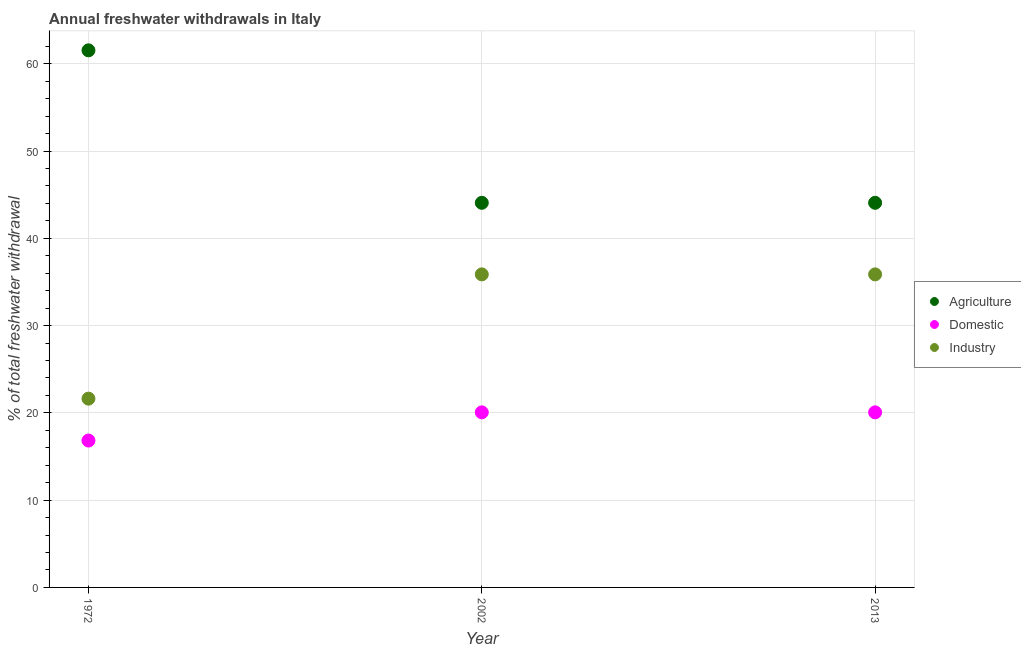How many different coloured dotlines are there?
Provide a succinct answer. 3. Is the number of dotlines equal to the number of legend labels?
Your response must be concise. Yes. What is the percentage of freshwater withdrawal for domestic purposes in 2013?
Give a very brief answer. 20.06. Across all years, what is the maximum percentage of freshwater withdrawal for industry?
Your answer should be very brief. 35.87. Across all years, what is the minimum percentage of freshwater withdrawal for agriculture?
Keep it short and to the point. 44.07. What is the total percentage of freshwater withdrawal for domestic purposes in the graph?
Offer a terse response. 56.95. What is the difference between the percentage of freshwater withdrawal for agriculture in 1972 and that in 2013?
Provide a succinct answer. 17.47. What is the difference between the percentage of freshwater withdrawal for domestic purposes in 2013 and the percentage of freshwater withdrawal for agriculture in 2002?
Give a very brief answer. -24.01. What is the average percentage of freshwater withdrawal for domestic purposes per year?
Your response must be concise. 18.98. In the year 2013, what is the difference between the percentage of freshwater withdrawal for agriculture and percentage of freshwater withdrawal for industry?
Provide a succinct answer. 8.2. In how many years, is the percentage of freshwater withdrawal for agriculture greater than 54 %?
Provide a short and direct response. 1. What is the ratio of the percentage of freshwater withdrawal for industry in 2002 to that in 2013?
Provide a succinct answer. 1. Is the percentage of freshwater withdrawal for industry in 2002 less than that in 2013?
Provide a short and direct response. No. What is the difference between the highest and the second highest percentage of freshwater withdrawal for agriculture?
Your answer should be compact. 17.47. What is the difference between the highest and the lowest percentage of freshwater withdrawal for industry?
Ensure brevity in your answer.  14.24. In how many years, is the percentage of freshwater withdrawal for industry greater than the average percentage of freshwater withdrawal for industry taken over all years?
Your answer should be compact. 2. Is it the case that in every year, the sum of the percentage of freshwater withdrawal for agriculture and percentage of freshwater withdrawal for domestic purposes is greater than the percentage of freshwater withdrawal for industry?
Your response must be concise. Yes. Does the percentage of freshwater withdrawal for domestic purposes monotonically increase over the years?
Keep it short and to the point. No. Is the percentage of freshwater withdrawal for industry strictly greater than the percentage of freshwater withdrawal for agriculture over the years?
Provide a succinct answer. No. How many dotlines are there?
Keep it short and to the point. 3. How many years are there in the graph?
Your response must be concise. 3. Are the values on the major ticks of Y-axis written in scientific E-notation?
Your answer should be compact. No. Does the graph contain any zero values?
Provide a succinct answer. No. How many legend labels are there?
Offer a terse response. 3. What is the title of the graph?
Give a very brief answer. Annual freshwater withdrawals in Italy. What is the label or title of the X-axis?
Keep it short and to the point. Year. What is the label or title of the Y-axis?
Offer a very short reply. % of total freshwater withdrawal. What is the % of total freshwater withdrawal in Agriculture in 1972?
Your answer should be compact. 61.54. What is the % of total freshwater withdrawal in Domestic in 1972?
Your answer should be compact. 16.83. What is the % of total freshwater withdrawal of Industry in 1972?
Make the answer very short. 21.63. What is the % of total freshwater withdrawal of Agriculture in 2002?
Give a very brief answer. 44.07. What is the % of total freshwater withdrawal in Domestic in 2002?
Your response must be concise. 20.06. What is the % of total freshwater withdrawal in Industry in 2002?
Ensure brevity in your answer.  35.87. What is the % of total freshwater withdrawal in Agriculture in 2013?
Your answer should be compact. 44.07. What is the % of total freshwater withdrawal of Domestic in 2013?
Your answer should be compact. 20.06. What is the % of total freshwater withdrawal of Industry in 2013?
Keep it short and to the point. 35.87. Across all years, what is the maximum % of total freshwater withdrawal in Agriculture?
Your response must be concise. 61.54. Across all years, what is the maximum % of total freshwater withdrawal of Domestic?
Make the answer very short. 20.06. Across all years, what is the maximum % of total freshwater withdrawal in Industry?
Your response must be concise. 35.87. Across all years, what is the minimum % of total freshwater withdrawal of Agriculture?
Provide a short and direct response. 44.07. Across all years, what is the minimum % of total freshwater withdrawal in Domestic?
Give a very brief answer. 16.83. Across all years, what is the minimum % of total freshwater withdrawal in Industry?
Your response must be concise. 21.63. What is the total % of total freshwater withdrawal in Agriculture in the graph?
Provide a short and direct response. 149.68. What is the total % of total freshwater withdrawal of Domestic in the graph?
Keep it short and to the point. 56.95. What is the total % of total freshwater withdrawal of Industry in the graph?
Keep it short and to the point. 93.37. What is the difference between the % of total freshwater withdrawal of Agriculture in 1972 and that in 2002?
Offer a terse response. 17.47. What is the difference between the % of total freshwater withdrawal of Domestic in 1972 and that in 2002?
Give a very brief answer. -3.23. What is the difference between the % of total freshwater withdrawal of Industry in 1972 and that in 2002?
Ensure brevity in your answer.  -14.24. What is the difference between the % of total freshwater withdrawal in Agriculture in 1972 and that in 2013?
Provide a succinct answer. 17.47. What is the difference between the % of total freshwater withdrawal in Domestic in 1972 and that in 2013?
Provide a short and direct response. -3.23. What is the difference between the % of total freshwater withdrawal in Industry in 1972 and that in 2013?
Ensure brevity in your answer.  -14.24. What is the difference between the % of total freshwater withdrawal in Industry in 2002 and that in 2013?
Offer a terse response. 0. What is the difference between the % of total freshwater withdrawal in Agriculture in 1972 and the % of total freshwater withdrawal in Domestic in 2002?
Your answer should be very brief. 41.48. What is the difference between the % of total freshwater withdrawal of Agriculture in 1972 and the % of total freshwater withdrawal of Industry in 2002?
Offer a terse response. 25.67. What is the difference between the % of total freshwater withdrawal of Domestic in 1972 and the % of total freshwater withdrawal of Industry in 2002?
Give a very brief answer. -19.04. What is the difference between the % of total freshwater withdrawal of Agriculture in 1972 and the % of total freshwater withdrawal of Domestic in 2013?
Offer a terse response. 41.48. What is the difference between the % of total freshwater withdrawal of Agriculture in 1972 and the % of total freshwater withdrawal of Industry in 2013?
Offer a terse response. 25.67. What is the difference between the % of total freshwater withdrawal in Domestic in 1972 and the % of total freshwater withdrawal in Industry in 2013?
Provide a short and direct response. -19.04. What is the difference between the % of total freshwater withdrawal of Agriculture in 2002 and the % of total freshwater withdrawal of Domestic in 2013?
Provide a short and direct response. 24.01. What is the difference between the % of total freshwater withdrawal in Agriculture in 2002 and the % of total freshwater withdrawal in Industry in 2013?
Make the answer very short. 8.2. What is the difference between the % of total freshwater withdrawal of Domestic in 2002 and the % of total freshwater withdrawal of Industry in 2013?
Your response must be concise. -15.81. What is the average % of total freshwater withdrawal of Agriculture per year?
Provide a short and direct response. 49.89. What is the average % of total freshwater withdrawal in Domestic per year?
Give a very brief answer. 18.98. What is the average % of total freshwater withdrawal in Industry per year?
Your response must be concise. 31.12. In the year 1972, what is the difference between the % of total freshwater withdrawal in Agriculture and % of total freshwater withdrawal in Domestic?
Your response must be concise. 44.71. In the year 1972, what is the difference between the % of total freshwater withdrawal of Agriculture and % of total freshwater withdrawal of Industry?
Give a very brief answer. 39.91. In the year 1972, what is the difference between the % of total freshwater withdrawal of Domestic and % of total freshwater withdrawal of Industry?
Ensure brevity in your answer.  -4.8. In the year 2002, what is the difference between the % of total freshwater withdrawal of Agriculture and % of total freshwater withdrawal of Domestic?
Give a very brief answer. 24.01. In the year 2002, what is the difference between the % of total freshwater withdrawal of Domestic and % of total freshwater withdrawal of Industry?
Give a very brief answer. -15.81. In the year 2013, what is the difference between the % of total freshwater withdrawal in Agriculture and % of total freshwater withdrawal in Domestic?
Give a very brief answer. 24.01. In the year 2013, what is the difference between the % of total freshwater withdrawal in Domestic and % of total freshwater withdrawal in Industry?
Your answer should be very brief. -15.81. What is the ratio of the % of total freshwater withdrawal of Agriculture in 1972 to that in 2002?
Your answer should be compact. 1.4. What is the ratio of the % of total freshwater withdrawal in Domestic in 1972 to that in 2002?
Your answer should be very brief. 0.84. What is the ratio of the % of total freshwater withdrawal in Industry in 1972 to that in 2002?
Provide a succinct answer. 0.6. What is the ratio of the % of total freshwater withdrawal in Agriculture in 1972 to that in 2013?
Ensure brevity in your answer.  1.4. What is the ratio of the % of total freshwater withdrawal of Domestic in 1972 to that in 2013?
Provide a short and direct response. 0.84. What is the ratio of the % of total freshwater withdrawal in Industry in 1972 to that in 2013?
Provide a short and direct response. 0.6. What is the ratio of the % of total freshwater withdrawal in Agriculture in 2002 to that in 2013?
Your answer should be very brief. 1. What is the ratio of the % of total freshwater withdrawal of Domestic in 2002 to that in 2013?
Make the answer very short. 1. What is the ratio of the % of total freshwater withdrawal of Industry in 2002 to that in 2013?
Your answer should be very brief. 1. What is the difference between the highest and the second highest % of total freshwater withdrawal of Agriculture?
Keep it short and to the point. 17.47. What is the difference between the highest and the second highest % of total freshwater withdrawal in Domestic?
Your answer should be compact. 0. What is the difference between the highest and the lowest % of total freshwater withdrawal of Agriculture?
Offer a terse response. 17.47. What is the difference between the highest and the lowest % of total freshwater withdrawal in Domestic?
Your answer should be very brief. 3.23. What is the difference between the highest and the lowest % of total freshwater withdrawal in Industry?
Provide a succinct answer. 14.24. 